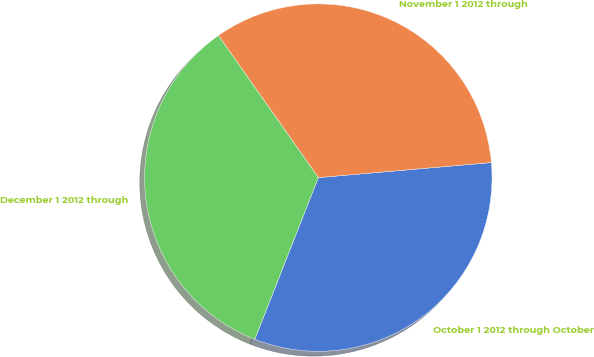<chart> <loc_0><loc_0><loc_500><loc_500><pie_chart><fcel>October 1 2012 through October<fcel>November 1 2012 through<fcel>December 1 2012 through<nl><fcel>32.34%<fcel>33.37%<fcel>34.29%<nl></chart> 